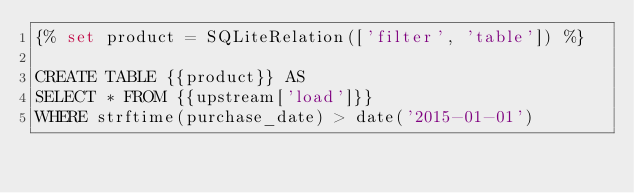Convert code to text. <code><loc_0><loc_0><loc_500><loc_500><_SQL_>{% set product = SQLiteRelation(['filter', 'table']) %}

CREATE TABLE {{product}} AS
SELECT * FROM {{upstream['load']}}
WHERE strftime(purchase_date) > date('2015-01-01')</code> 